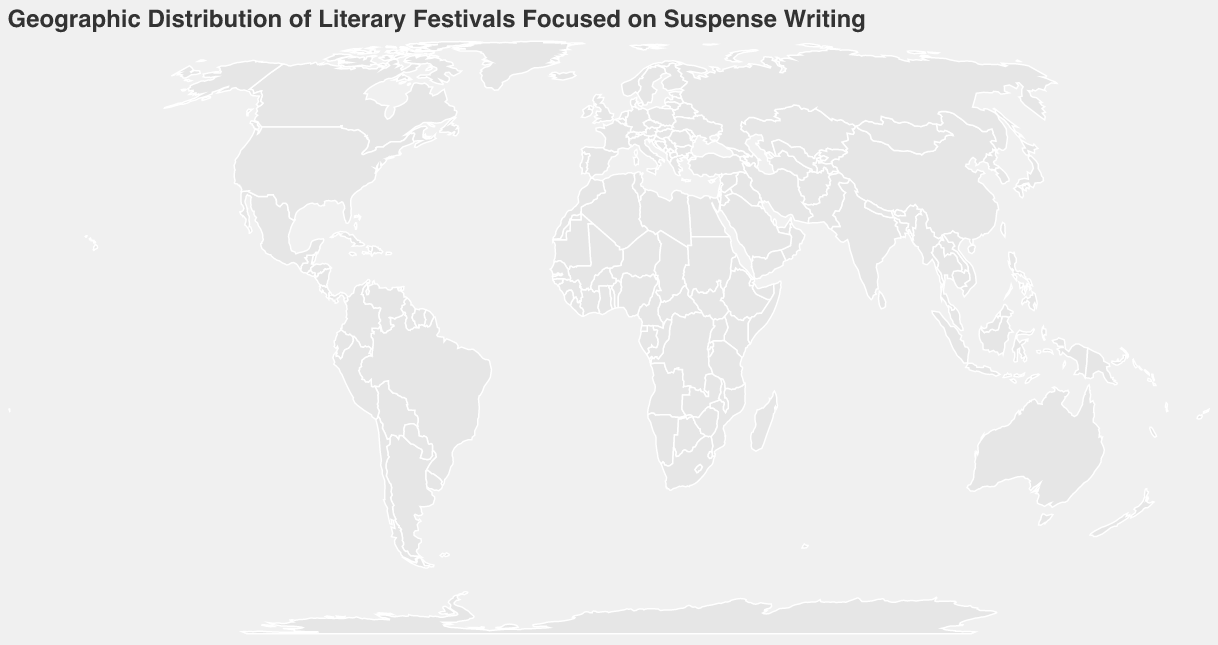What's the title of the geographic plot? The title of a plot is usually located at the top and describes what the plot is about. In this case, it says: "Geographic Distribution of Literary Festivals Focused on Suspense Writing."
Answer: Geographic Distribution of Literary Festivals Focused on Suspense Writing Which festival has the highest attendance? To find the festival with the highest attendance, look for the circle with the largest size, then check the tooltip or legend that displays the attendance numbers. The New York Suspense Symposium has the highest attendance with 3000 people.
Answer: New York Suspense Symposium How many festivals are depicted on the plot? Count the number of circles or festival points on the plot. Each point represents a festival. There are 10 distinct points indicating 10 festivals.
Answer: 10 Which festival focuses on "Twist Endings in Australian Fiction"? Identify the festival by examining the tooltip information for the focus areas. The Sydney Suspense Writers Retreat is the one that focuses on "Twist Endings in Australian Fiction."
Answer: Sydney Suspense Writers Retreat What is the total attendance of the festivals in Europe? Locate the festivals in Europe (London, Paris, Rome, Berlin, Moscow), sum their attendance: London (2500) + Paris (1800) + Rome (2200) + Berlin (2800) + Moscow (1000) = 10300.
Answer: 10300 Which city in the Southern Hemisphere hosts a festival, and what is its name? Look for cities located below the equator (Latitude less than 0). Sydney and Rio are in the Southern Hemisphere. Sydney hosts the "Sydney Suspense Writers Retreat," and Rio hosts the "Rio Suspense Writing Carnival."
Answer: Sydney, Sydney Suspense Writers Retreat (also Rio, Rio Suspense Writing Carnival) Compare the attendance between the Berlin and Paris festivals. Which one has more attendees and by how much? Check the attendance numbers for Berlin (2800) and Paris (1800). Subtract Paris's attendance from Berlin's attendance to find the difference. Berlin has 1000 more attendees.
Answer: Berlin has 1000 more attendees Are there any festivals in Asia? If so, which ones and where are they located? Identify locations in Asia by their longitudes and latitudes. Tokyo is in Asia, hosting the "Tokyo Tension Literary Workshop."
Answer: Tokyo Tension Literary Workshop in Tokyo 